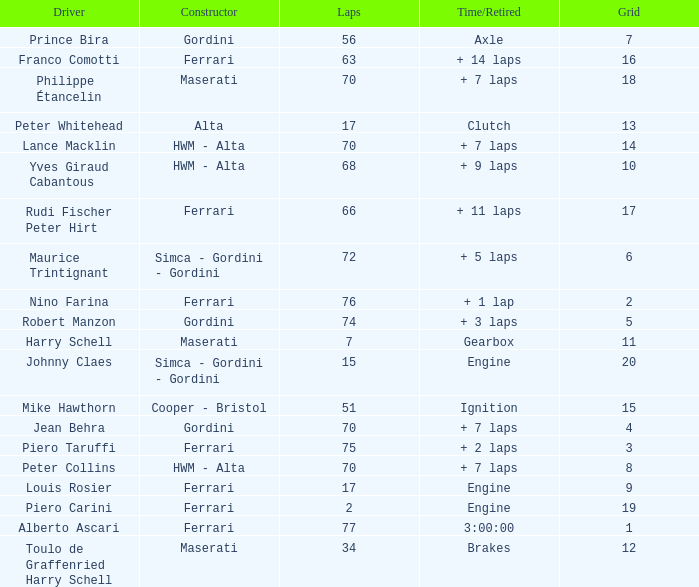Who drove the car with over 66 laps with a grid of 5? Robert Manzon. 